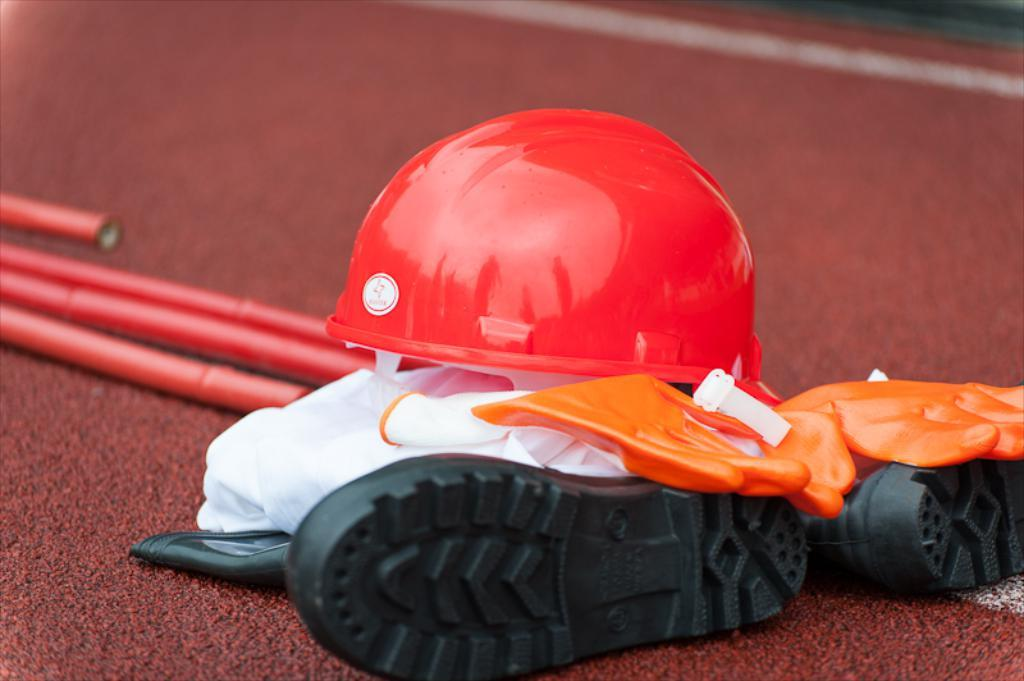What type of protective gear is visible in the image? There is a helmet in the image. What type of footwear is present in the image? There is a pair of shoes in the image. What type of hand covering is visible in the image? There is a pair of gloves in the image. What type of long, thin objects are present in the image? There are sticks in the image. Where are all these items located in the image? All of these items are placed on the floor. What type of prose can be seen written on the helmet in the image? There is no prose written on the helmet in the image; it is a protective gear item. 